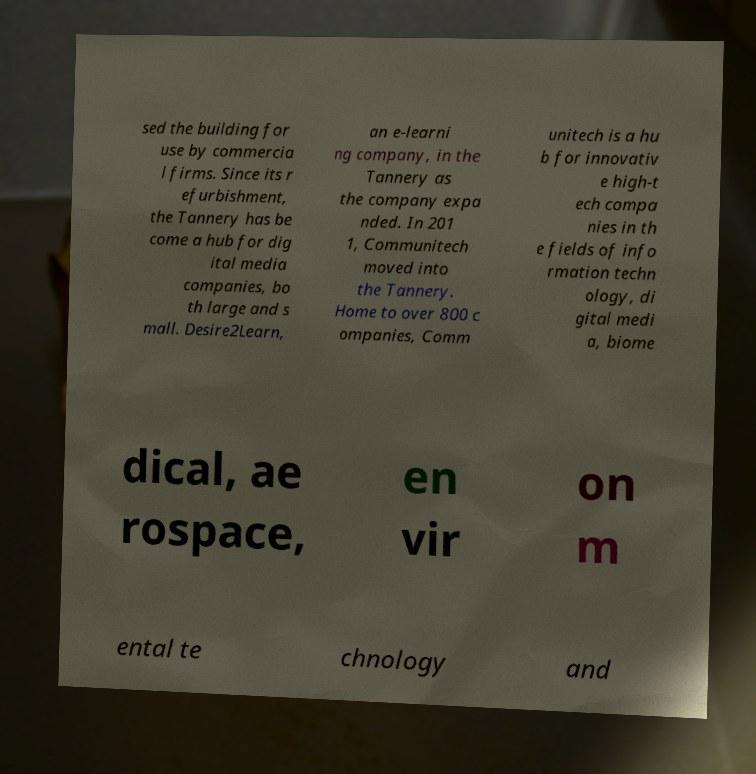Please read and relay the text visible in this image. What does it say? sed the building for use by commercia l firms. Since its r efurbishment, the Tannery has be come a hub for dig ital media companies, bo th large and s mall. Desire2Learn, an e-learni ng company, in the Tannery as the company expa nded. In 201 1, Communitech moved into the Tannery. Home to over 800 c ompanies, Comm unitech is a hu b for innovativ e high-t ech compa nies in th e fields of info rmation techn ology, di gital medi a, biome dical, ae rospace, en vir on m ental te chnology and 